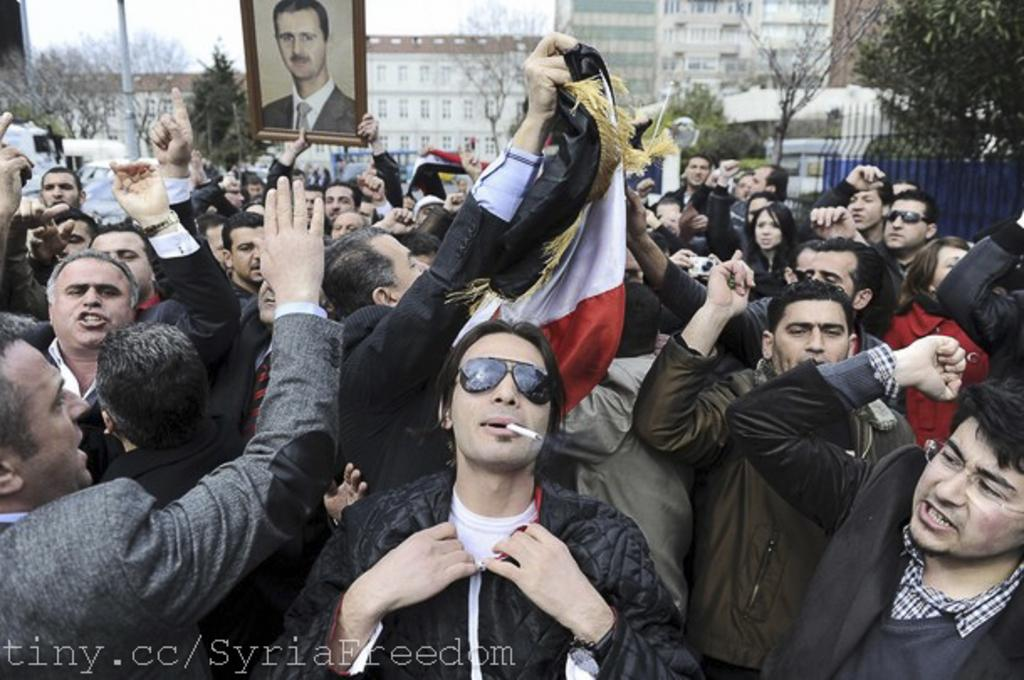What are the people in the image doing? The people in the image are standing and holding photo frames and flags. What can be seen in the background of the image? There are trees and buildings visible in the background of the image. What type of punishment is being administered to the building in the image? There is no punishment being administered to any building in the image. What ring is being worn by the people in the image? There is no ring visible on any of the people in the image. 